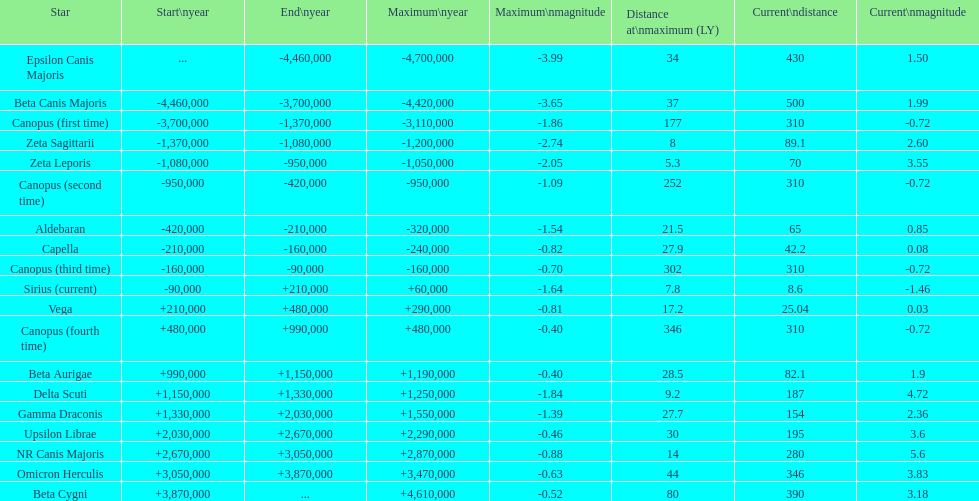Is the current magnitude of capella higher than that of vega? Yes. Give me the full table as a dictionary. {'header': ['Star', 'Start\\nyear', 'End\\nyear', 'Maximum\\nyear', 'Maximum\\nmagnitude', 'Distance at\\nmaximum (LY)', 'Current\\ndistance', 'Current\\nmagnitude'], 'rows': [['Epsilon Canis Majoris', '...', '-4,460,000', '-4,700,000', '-3.99', '34', '430', '1.50'], ['Beta Canis Majoris', '-4,460,000', '-3,700,000', '-4,420,000', '-3.65', '37', '500', '1.99'], ['Canopus (first time)', '-3,700,000', '-1,370,000', '-3,110,000', '-1.86', '177', '310', '-0.72'], ['Zeta Sagittarii', '-1,370,000', '-1,080,000', '-1,200,000', '-2.74', '8', '89.1', '2.60'], ['Zeta Leporis', '-1,080,000', '-950,000', '-1,050,000', '-2.05', '5.3', '70', '3.55'], ['Canopus (second time)', '-950,000', '-420,000', '-950,000', '-1.09', '252', '310', '-0.72'], ['Aldebaran', '-420,000', '-210,000', '-320,000', '-1.54', '21.5', '65', '0.85'], ['Capella', '-210,000', '-160,000', '-240,000', '-0.82', '27.9', '42.2', '0.08'], ['Canopus (third time)', '-160,000', '-90,000', '-160,000', '-0.70', '302', '310', '-0.72'], ['Sirius (current)', '-90,000', '+210,000', '+60,000', '-1.64', '7.8', '8.6', '-1.46'], ['Vega', '+210,000', '+480,000', '+290,000', '-0.81', '17.2', '25.04', '0.03'], ['Canopus (fourth time)', '+480,000', '+990,000', '+480,000', '-0.40', '346', '310', '-0.72'], ['Beta Aurigae', '+990,000', '+1,150,000', '+1,190,000', '-0.40', '28.5', '82.1', '1.9'], ['Delta Scuti', '+1,150,000', '+1,330,000', '+1,250,000', '-1.84', '9.2', '187', '4.72'], ['Gamma Draconis', '+1,330,000', '+2,030,000', '+1,550,000', '-1.39', '27.7', '154', '2.36'], ['Upsilon Librae', '+2,030,000', '+2,670,000', '+2,290,000', '-0.46', '30', '195', '3.6'], ['NR Canis Majoris', '+2,670,000', '+3,050,000', '+2,870,000', '-0.88', '14', '280', '5.6'], ['Omicron Herculis', '+3,050,000', '+3,870,000', '+3,470,000', '-0.63', '44', '346', '3.83'], ['Beta Cygni', '+3,870,000', '...', '+4,610,000', '-0.52', '80', '390', '3.18']]} 